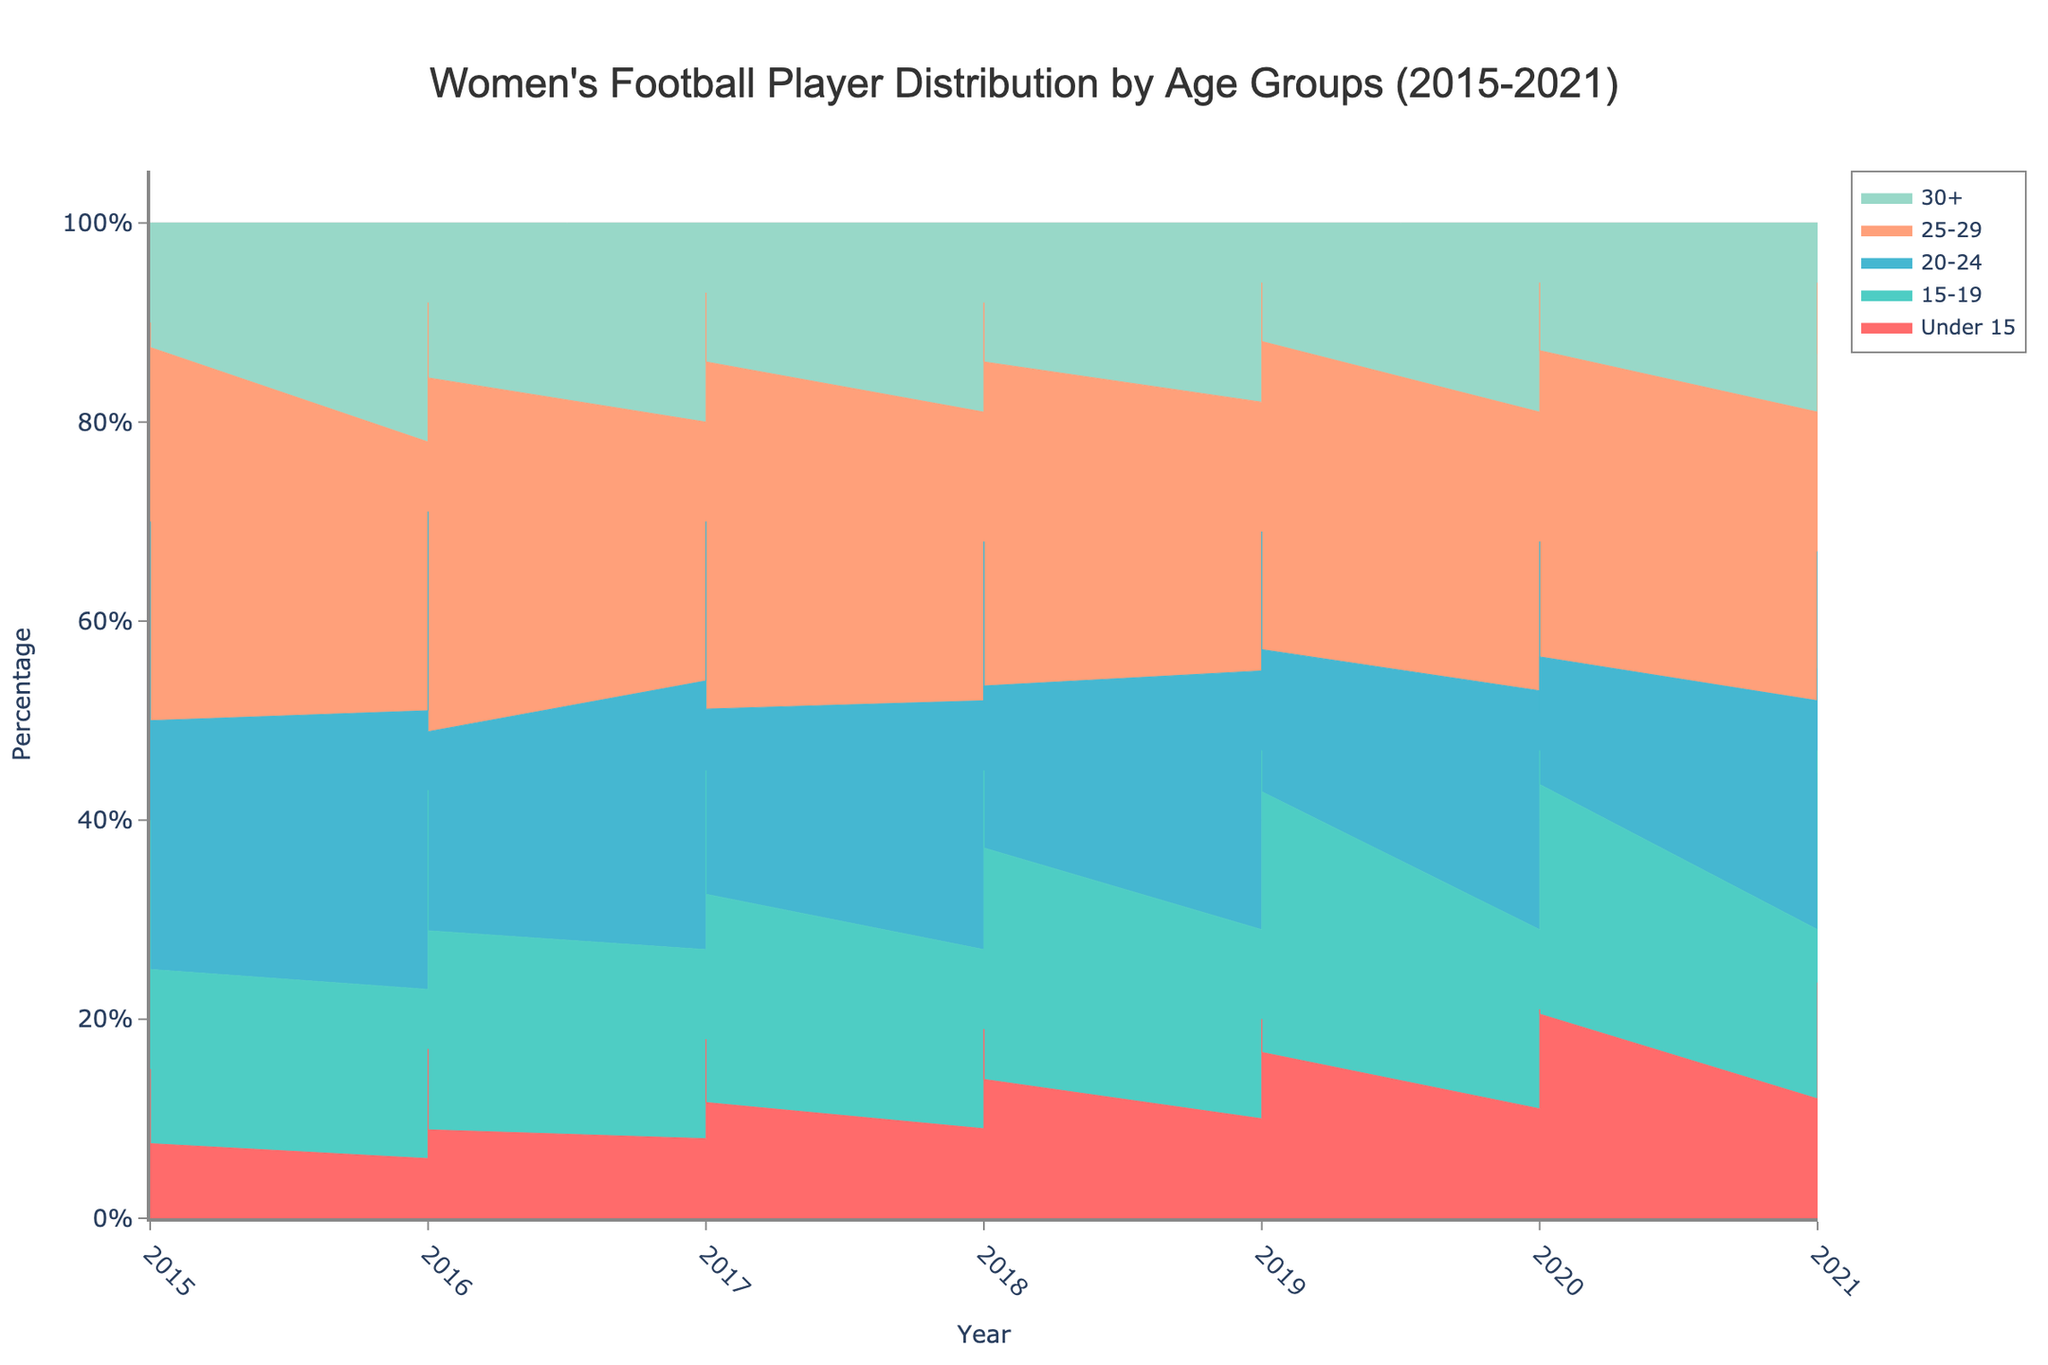What is the title of the figure? The title of the figure is usually located at the top center and provides an overview of what the figure represents. By looking at the top center of the figure, you can see that the title is "Women's Football Player Distribution by Age Groups (2015-2021)"
Answer: Women's Football Player Distribution by Age Groups (2015-2021) Which age group has the largest area in 2015? To determine which age group has the largest area, look for the age group with the highest percentage at the start of the chart (2015). Observe the layers and see which one is the thickest at that point. The "20-24" group has the largest area in 2015.
Answer: 20-24 How did the percentage of the "Under 15" age group change from 2015 to 2021? First, identify the "Under 15" age group in the figure by its corresponding color. Then, observe and compare the height of the "Under 15" layer in 2015 and 2021. The percentage for the "Under 15" group increased from 2015 to 2021.
Answer: Increased Which region has the highest proportion of players aged 15-19 in 2018? Identify the year 2018 on the x-axis and see the proportion for the "15-19" age group. Compare the regions by observing the thickness of this age group’s layer in Karachi, Lahore, Islamabad, Peshawar, and Quetta. Lahore has the highest proportion in 2018.
Answer: Lahore Is there a year where the percentage of players aged 30+ was the same across all regions? Scan through the figure and look for a line where the percentage distribution appears constant for the "30+" age group across all regions. Check if there’s a flat line for "30+" across all vertical sections (regions) for any specific year. There is no such year where the percentage is uniform across all regions.
Answer: No What trend can be observed for the "25-29" age group from 2015 to 2021? Follow the trail of the "25-29" layer from 2015 to 2021. Notice the changes in the thickness of this layer across these years. The percentage of the "25-29" age group generally increased over the period.
Answer: Increased By how much did the percentage of players aged "20-24" change in Quetta from 2015 to 2021? Identify the "20-24" age group color and follow it specifically for Quetta from 2015 to 2021. Look at the starting and ending points of the layer for this age group and calculate the change in percentage. There is a 60% decrease for the "20-24" age group in Quetta.
Answer: Decreased by 60% Which age group shows the most consistent percentage over the years? Observe the layers for each age group across all years and see which layer maintains a fairly uniform thickness throughout the chart. The "30+" age group appears to have the most consistent percentage over time.
Answer: 30+ In which year did Karachi have the lowest percentage of players in the "15-19" age group? Identify the "15-19" age group color and follow its percentage for Karachi as indicated for each year on the x-axis. Notice the year with the smallest height for this group. The year 2021 shows the lowest percentage for the "15-19" age group in Karachi.
Answer: 2021 